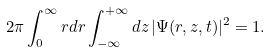Convert formula to latex. <formula><loc_0><loc_0><loc_500><loc_500>2 \pi \int _ { 0 } ^ { \infty } r d r \int _ { - \infty } ^ { + \infty } d z \, | \Psi ( r , z , t ) | ^ { 2 } = 1 .</formula> 